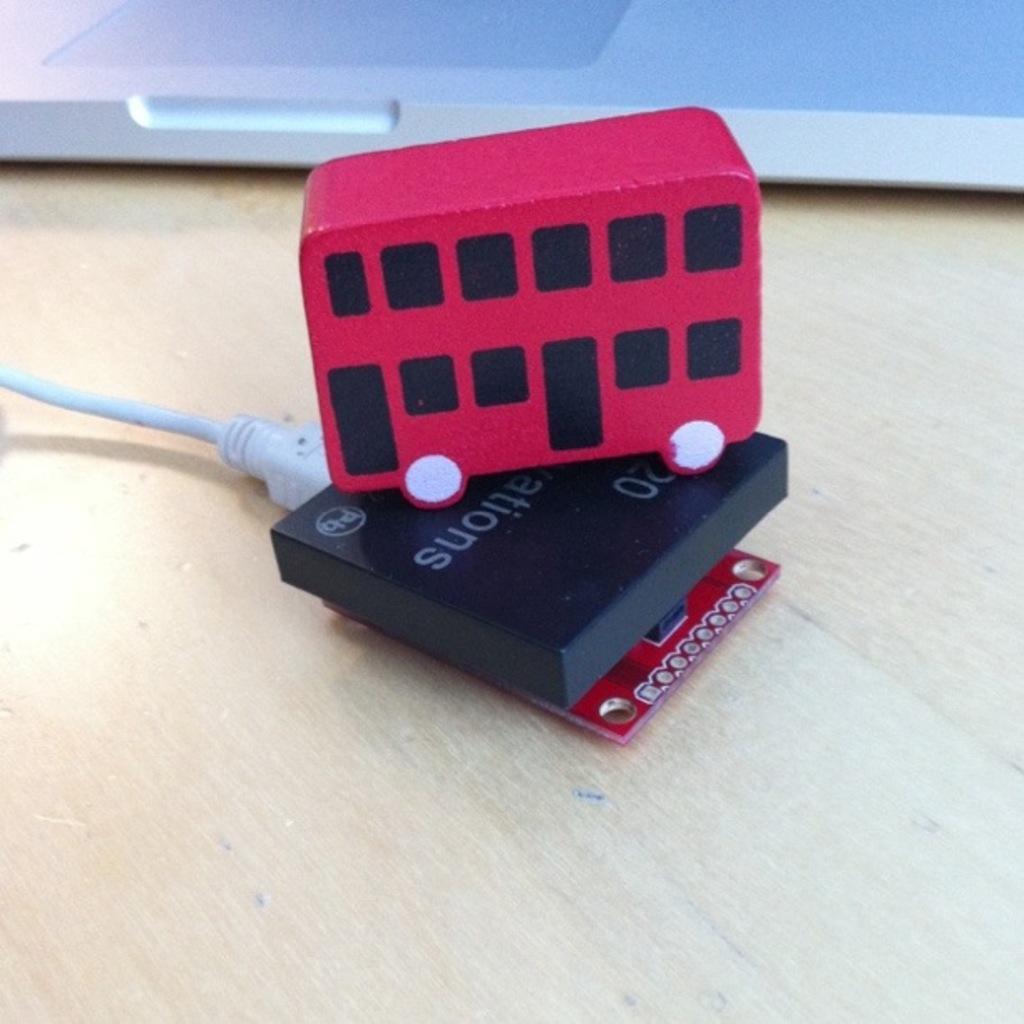How would you summarize this image in a sentence or two? In this image I can see toy bus which is in red and black color. It is on the electronic gadget. We can see chip. Back Side I can see laptop. There are on the wooden table. 